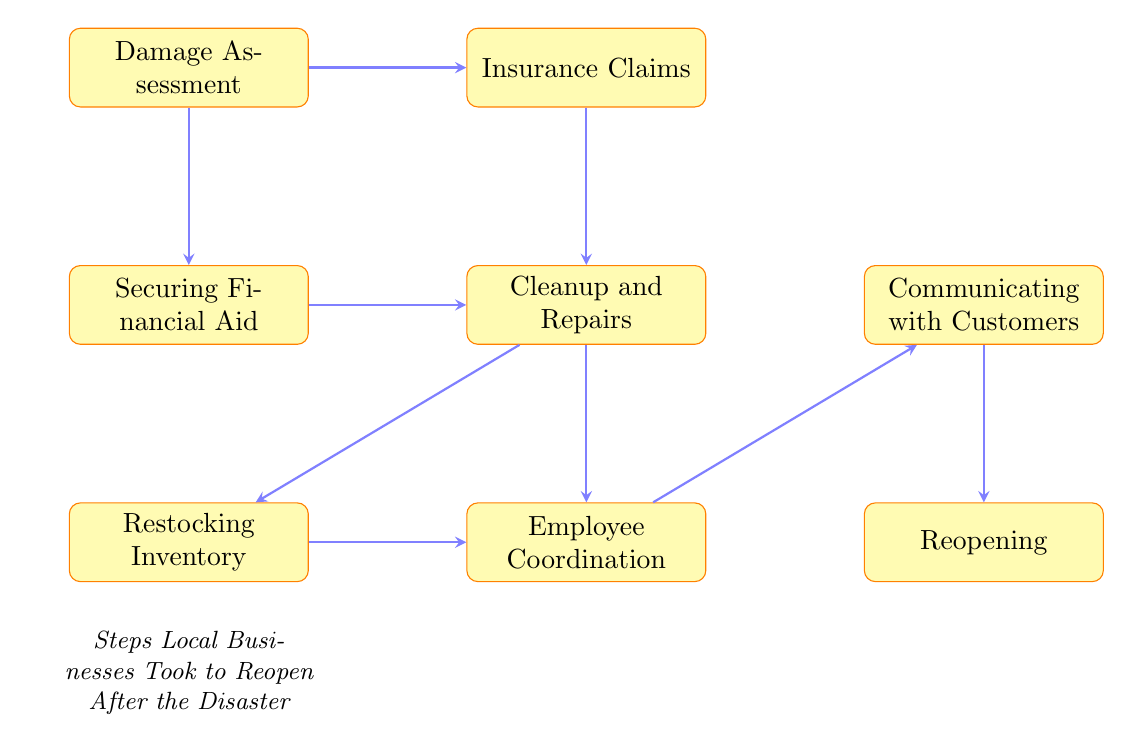What is the first step in the reopening process? The first step is "Damage Assessment", which is at the top of the flow chart. It represents the initial action local businesses took after the disaster.
Answer: Damage Assessment How many total steps are indicated in this flow chart? There are eight steps listed in the flow chart, from "Damage Assessment" to "Reopening". Counting each distinct node provides the total number of steps.
Answer: Eight Which two steps come after "Insurance Claims"? The two steps that follow "Insurance Claims" are "Cleanup and Repairs" and "Securing Financial Aid". Both steps are positioned below "Insurance Claims" in the diagram, showing the sequence of actions.
Answer: Cleanup and Repairs, Securing Financial Aid What step is directly connected to both "Cleanup and Repairs" and "Restocking Inventory"? The step that is directly connected to both "Cleanup and Repairs" and "Restocking Inventory" is "Employee Coordination". It follows both steps, indicating employee organization happens after the cleanup and restocking.
Answer: Employee Coordination What is the final step in this process? The final step in the process is "Reopening". It is the last node in the flow chart, indicating that businesses reopen after completing all previous steps.
Answer: Reopening Which step involves communicating with customers? The step involving communicating with customers is "Communicating with Customers". It is positioned directly after "Employee Coordination" in the process flow, highlighting the importance of customer outreach after employee organization.
Answer: Communicating with Customers Which step comes before "Restocking Inventory"? The step that comes before "Restocking Inventory" is "Cleanup and Repairs". This can be seen by following the arrows in the flow chart that indicate the order of operations after the disaster.
Answer: Cleanup and Repairs What process occurs after securing financial aid? After securing financial aid, "Cleanup and Repairs" occurs. This is indicated by the arrow that leads from "Securing Financial Aid" to "Cleanup and Repairs", showing the sequence of responses to the disaster.
Answer: Cleanup and Repairs How many steps are above the "Reopening" step? There are six steps above the "Reopening" step. By counting the nodes from "Damage Assessment" to "Employee Coordination", we can determine the total.
Answer: Six 